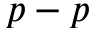Convert formula to latex. <formula><loc_0><loc_0><loc_500><loc_500>p - p</formula> 